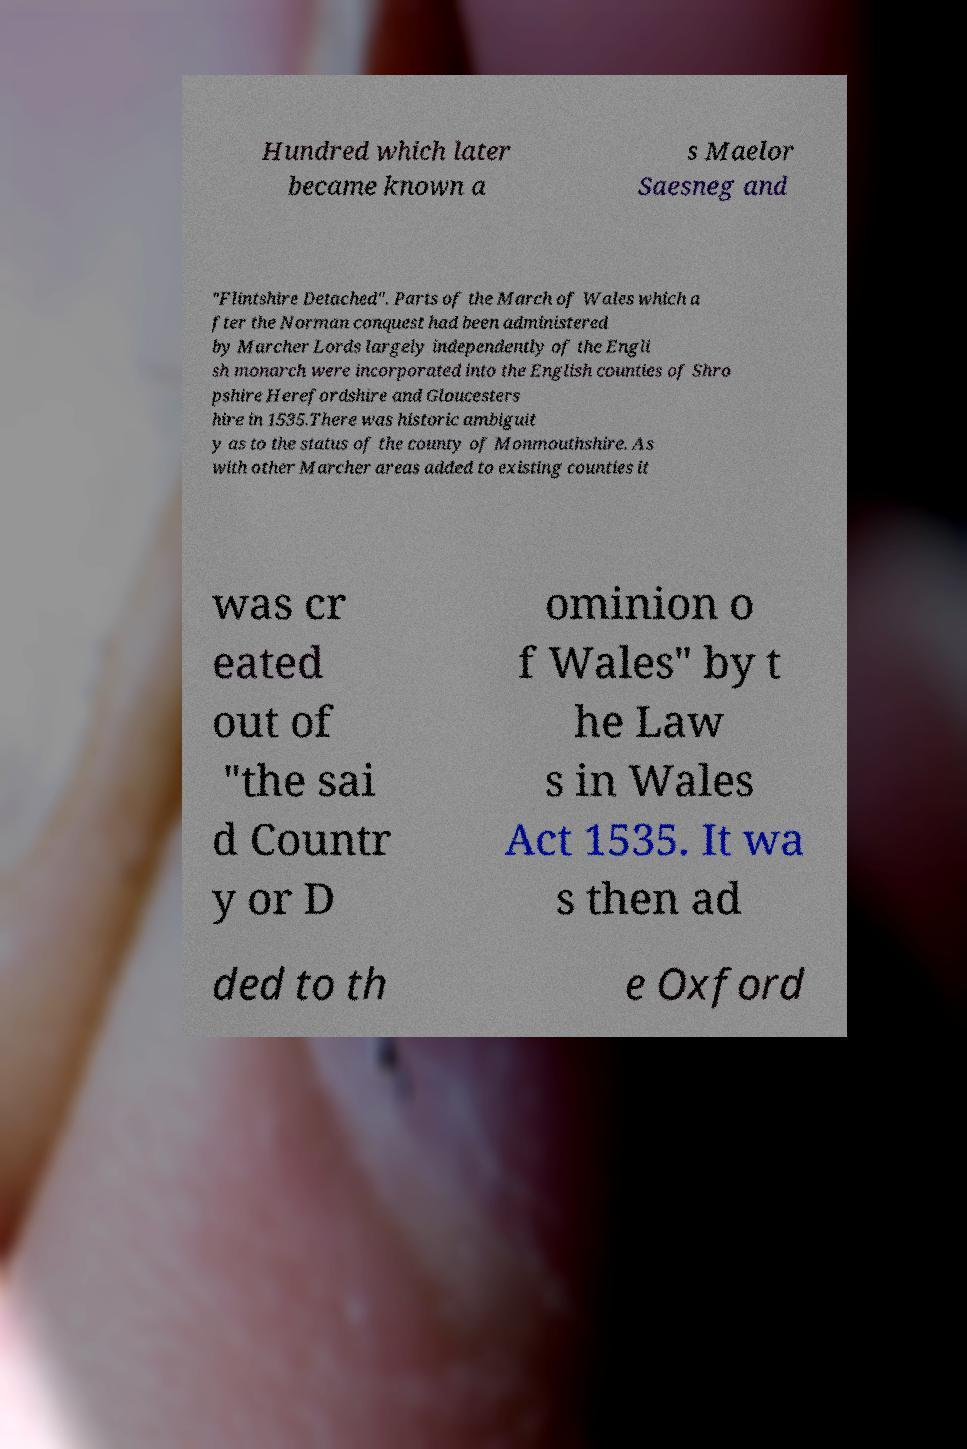Could you extract and type out the text from this image? Hundred which later became known a s Maelor Saesneg and "Flintshire Detached". Parts of the March of Wales which a fter the Norman conquest had been administered by Marcher Lords largely independently of the Engli sh monarch were incorporated into the English counties of Shro pshire Herefordshire and Gloucesters hire in 1535.There was historic ambiguit y as to the status of the county of Monmouthshire. As with other Marcher areas added to existing counties it was cr eated out of "the sai d Countr y or D ominion o f Wales" by t he Law s in Wales Act 1535. It wa s then ad ded to th e Oxford 